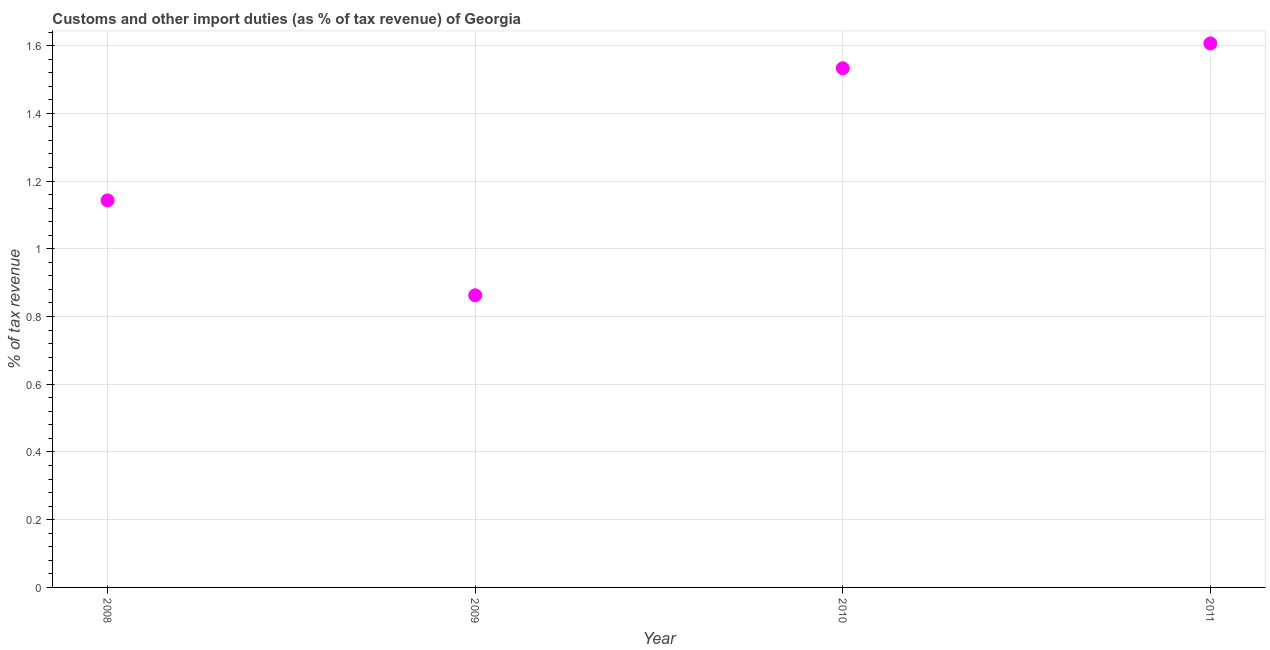What is the customs and other import duties in 2009?
Ensure brevity in your answer.  0.86. Across all years, what is the maximum customs and other import duties?
Offer a terse response. 1.61. Across all years, what is the minimum customs and other import duties?
Provide a succinct answer. 0.86. What is the sum of the customs and other import duties?
Make the answer very short. 5.14. What is the difference between the customs and other import duties in 2008 and 2010?
Your answer should be very brief. -0.39. What is the average customs and other import duties per year?
Give a very brief answer. 1.29. What is the median customs and other import duties?
Ensure brevity in your answer.  1.34. In how many years, is the customs and other import duties greater than 0.52 %?
Ensure brevity in your answer.  4. What is the ratio of the customs and other import duties in 2008 to that in 2010?
Offer a terse response. 0.75. Is the customs and other import duties in 2008 less than that in 2011?
Keep it short and to the point. Yes. What is the difference between the highest and the second highest customs and other import duties?
Offer a terse response. 0.07. Is the sum of the customs and other import duties in 2009 and 2011 greater than the maximum customs and other import duties across all years?
Offer a very short reply. Yes. What is the difference between the highest and the lowest customs and other import duties?
Offer a very short reply. 0.74. Does the customs and other import duties monotonically increase over the years?
Make the answer very short. No. How many dotlines are there?
Keep it short and to the point. 1. How many years are there in the graph?
Ensure brevity in your answer.  4. Does the graph contain grids?
Offer a very short reply. Yes. What is the title of the graph?
Make the answer very short. Customs and other import duties (as % of tax revenue) of Georgia. What is the label or title of the Y-axis?
Offer a terse response. % of tax revenue. What is the % of tax revenue in 2008?
Your answer should be very brief. 1.14. What is the % of tax revenue in 2009?
Keep it short and to the point. 0.86. What is the % of tax revenue in 2010?
Your answer should be very brief. 1.53. What is the % of tax revenue in 2011?
Provide a short and direct response. 1.61. What is the difference between the % of tax revenue in 2008 and 2009?
Give a very brief answer. 0.28. What is the difference between the % of tax revenue in 2008 and 2010?
Keep it short and to the point. -0.39. What is the difference between the % of tax revenue in 2008 and 2011?
Give a very brief answer. -0.46. What is the difference between the % of tax revenue in 2009 and 2010?
Your answer should be very brief. -0.67. What is the difference between the % of tax revenue in 2009 and 2011?
Ensure brevity in your answer.  -0.74. What is the difference between the % of tax revenue in 2010 and 2011?
Provide a succinct answer. -0.07. What is the ratio of the % of tax revenue in 2008 to that in 2009?
Ensure brevity in your answer.  1.32. What is the ratio of the % of tax revenue in 2008 to that in 2010?
Your response must be concise. 0.74. What is the ratio of the % of tax revenue in 2008 to that in 2011?
Your response must be concise. 0.71. What is the ratio of the % of tax revenue in 2009 to that in 2010?
Offer a terse response. 0.56. What is the ratio of the % of tax revenue in 2009 to that in 2011?
Ensure brevity in your answer.  0.54. What is the ratio of the % of tax revenue in 2010 to that in 2011?
Provide a short and direct response. 0.95. 